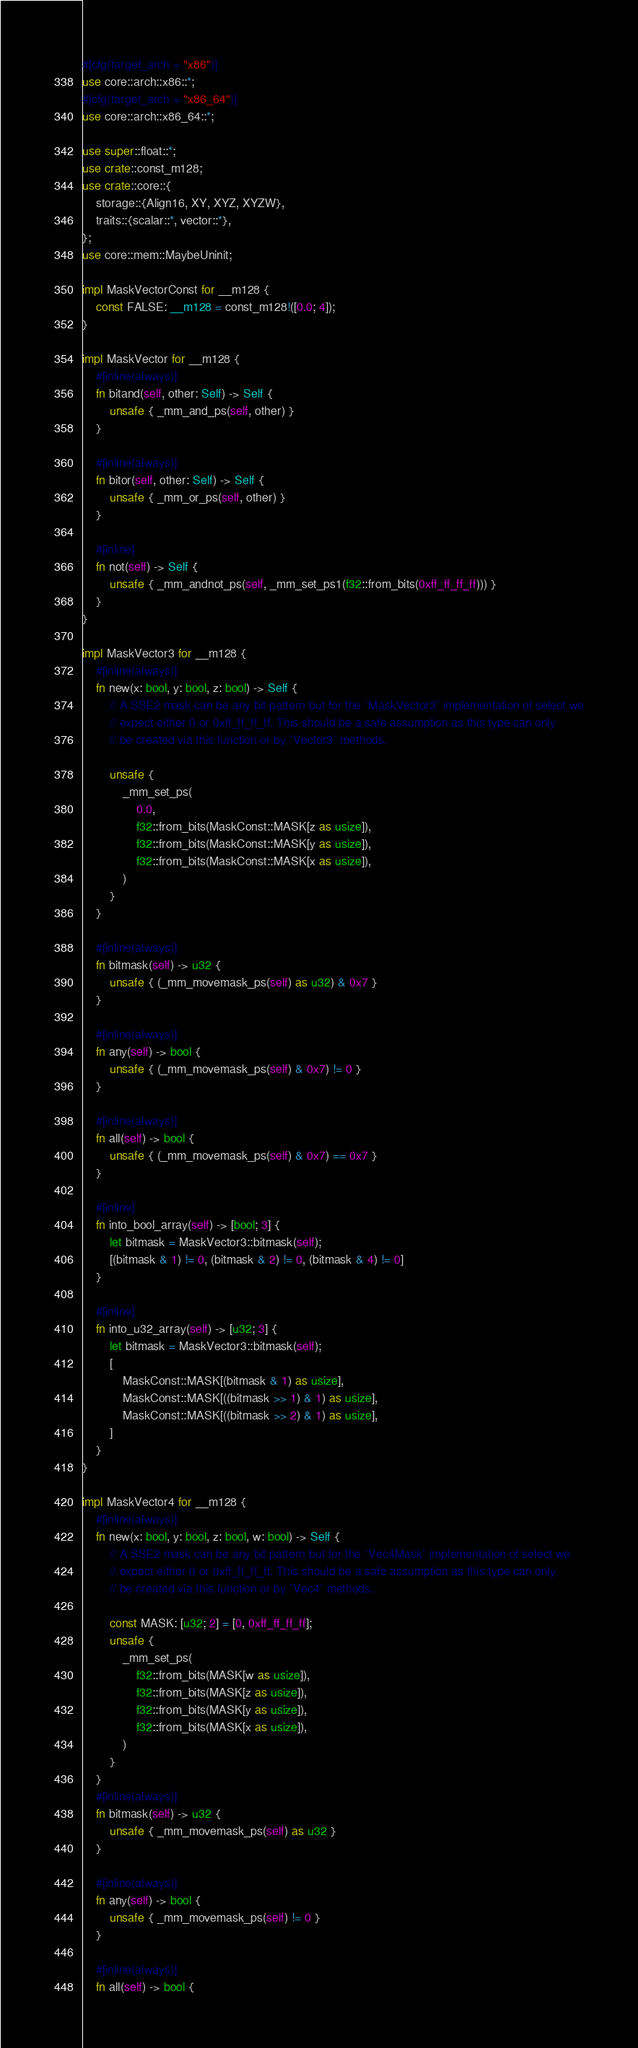<code> <loc_0><loc_0><loc_500><loc_500><_Rust_>#[cfg(target_arch = "x86")]
use core::arch::x86::*;
#[cfg(target_arch = "x86_64")]
use core::arch::x86_64::*;

use super::float::*;
use crate::const_m128;
use crate::core::{
    storage::{Align16, XY, XYZ, XYZW},
    traits::{scalar::*, vector::*},
};
use core::mem::MaybeUninit;

impl MaskVectorConst for __m128 {
    const FALSE: __m128 = const_m128!([0.0; 4]);
}

impl MaskVector for __m128 {
    #[inline(always)]
    fn bitand(self, other: Self) -> Self {
        unsafe { _mm_and_ps(self, other) }
    }

    #[inline(always)]
    fn bitor(self, other: Self) -> Self {
        unsafe { _mm_or_ps(self, other) }
    }

    #[inline]
    fn not(self) -> Self {
        unsafe { _mm_andnot_ps(self, _mm_set_ps1(f32::from_bits(0xff_ff_ff_ff))) }
    }
}

impl MaskVector3 for __m128 {
    #[inline(always)]
    fn new(x: bool, y: bool, z: bool) -> Self {
        // A SSE2 mask can be any bit pattern but for the `MaskVector3` implementation of select we
        // expect either 0 or 0xff_ff_ff_ff. This should be a safe assumption as this type can only
        // be created via this function or by `Vector3` methods.

        unsafe {
            _mm_set_ps(
                0.0,
                f32::from_bits(MaskConst::MASK[z as usize]),
                f32::from_bits(MaskConst::MASK[y as usize]),
                f32::from_bits(MaskConst::MASK[x as usize]),
            )
        }
    }

    #[inline(always)]
    fn bitmask(self) -> u32 {
        unsafe { (_mm_movemask_ps(self) as u32) & 0x7 }
    }

    #[inline(always)]
    fn any(self) -> bool {
        unsafe { (_mm_movemask_ps(self) & 0x7) != 0 }
    }

    #[inline(always)]
    fn all(self) -> bool {
        unsafe { (_mm_movemask_ps(self) & 0x7) == 0x7 }
    }

    #[inline]
    fn into_bool_array(self) -> [bool; 3] {
        let bitmask = MaskVector3::bitmask(self);
        [(bitmask & 1) != 0, (bitmask & 2) != 0, (bitmask & 4) != 0]
    }

    #[inline]
    fn into_u32_array(self) -> [u32; 3] {
        let bitmask = MaskVector3::bitmask(self);
        [
            MaskConst::MASK[(bitmask & 1) as usize],
            MaskConst::MASK[((bitmask >> 1) & 1) as usize],
            MaskConst::MASK[((bitmask >> 2) & 1) as usize],
        ]
    }
}

impl MaskVector4 for __m128 {
    #[inline(always)]
    fn new(x: bool, y: bool, z: bool, w: bool) -> Self {
        // A SSE2 mask can be any bit pattern but for the `Vec4Mask` implementation of select we
        // expect either 0 or 0xff_ff_ff_ff. This should be a safe assumption as this type can only
        // be created via this function or by `Vec4` methods.

        const MASK: [u32; 2] = [0, 0xff_ff_ff_ff];
        unsafe {
            _mm_set_ps(
                f32::from_bits(MASK[w as usize]),
                f32::from_bits(MASK[z as usize]),
                f32::from_bits(MASK[y as usize]),
                f32::from_bits(MASK[x as usize]),
            )
        }
    }
    #[inline(always)]
    fn bitmask(self) -> u32 {
        unsafe { _mm_movemask_ps(self) as u32 }
    }

    #[inline(always)]
    fn any(self) -> bool {
        unsafe { _mm_movemask_ps(self) != 0 }
    }

    #[inline(always)]
    fn all(self) -> bool {</code> 